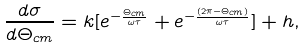<formula> <loc_0><loc_0><loc_500><loc_500>\frac { d \sigma } { d \Theta _ { c m } } = k [ e ^ { - \frac { \Theta _ { c m } } { \omega \tau } } + e ^ { - \frac { ( 2 \pi - \Theta _ { c m } ) } { \omega \tau } } ] + h ,</formula> 